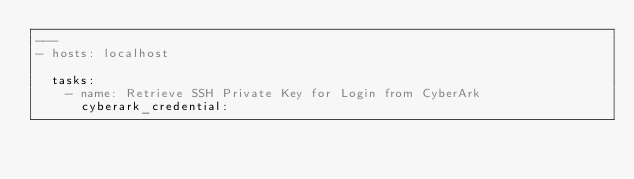<code> <loc_0><loc_0><loc_500><loc_500><_YAML_>---
- hosts: localhost

  tasks:
    - name: Retrieve SSH Private Key for Login from CyberArk
      cyberark_credential:</code> 